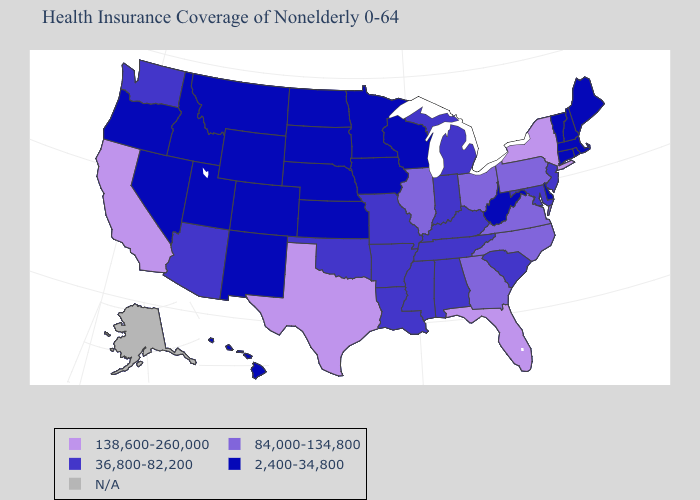What is the value of Delaware?
Be succinct. 2,400-34,800. Does Louisiana have the highest value in the USA?
Short answer required. No. Which states have the lowest value in the West?
Write a very short answer. Colorado, Hawaii, Idaho, Montana, Nevada, New Mexico, Oregon, Utah, Wyoming. Name the states that have a value in the range 138,600-260,000?
Quick response, please. California, Florida, New York, Texas. Name the states that have a value in the range 84,000-134,800?
Give a very brief answer. Georgia, Illinois, North Carolina, Ohio, Pennsylvania, Virginia. Name the states that have a value in the range N/A?
Be succinct. Alaska. What is the highest value in the West ?
Give a very brief answer. 138,600-260,000. Among the states that border Vermont , which have the highest value?
Concise answer only. New York. What is the highest value in the Northeast ?
Answer briefly. 138,600-260,000. What is the highest value in the USA?
Give a very brief answer. 138,600-260,000. Among the states that border Utah , which have the highest value?
Quick response, please. Arizona. What is the value of Georgia?
Quick response, please. 84,000-134,800. What is the value of Georgia?
Be succinct. 84,000-134,800. 